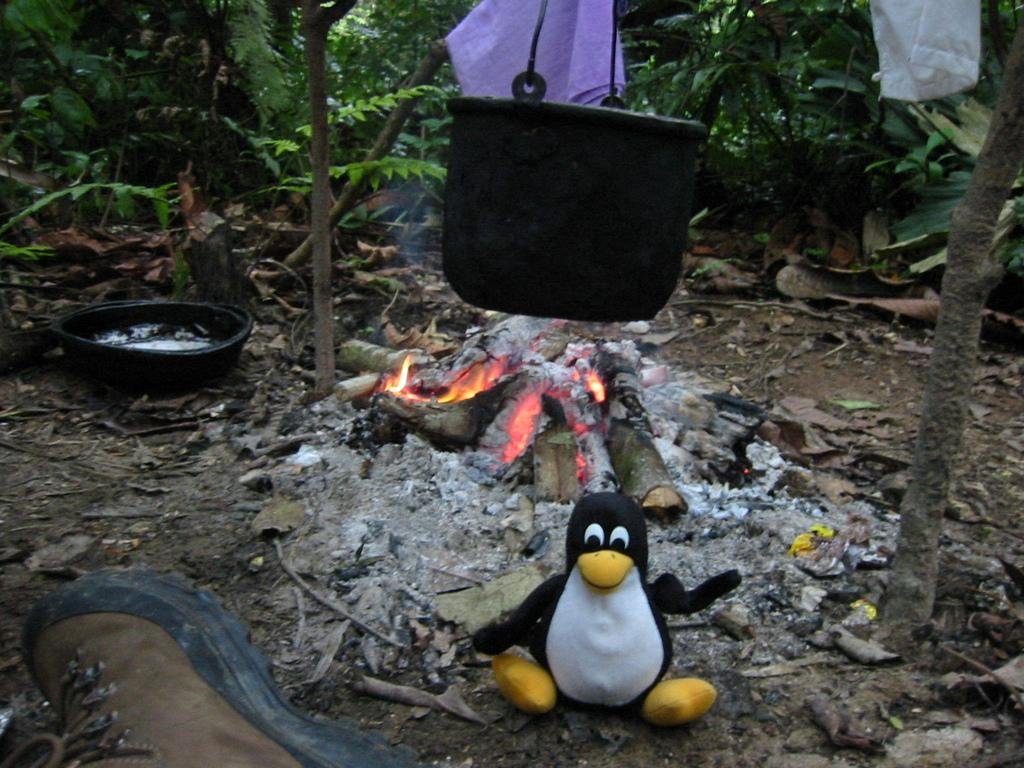What is hanging in the image? There is a black color container hanging in the image. What is happening on the ground in the image? There is fire on the ground in the image. What type of object can be seen in the image? There is a toy visible in the image. What else is hanging in the image besides the container? There are clothes hanging in the image. What type of natural elements are present in the image? There are trees present in the image. Can you see a tiger playing with paste in the image? There is no tiger or paste present in the image; it features a black color container, fire on the ground, a toy, clothes hanging, and trees. What type of pen is being used to draw on the trees in the image? There is no pen or drawing activity present in the image; it only shows a black color container, fire on the ground, a toy, clothes hanging, and trees. 